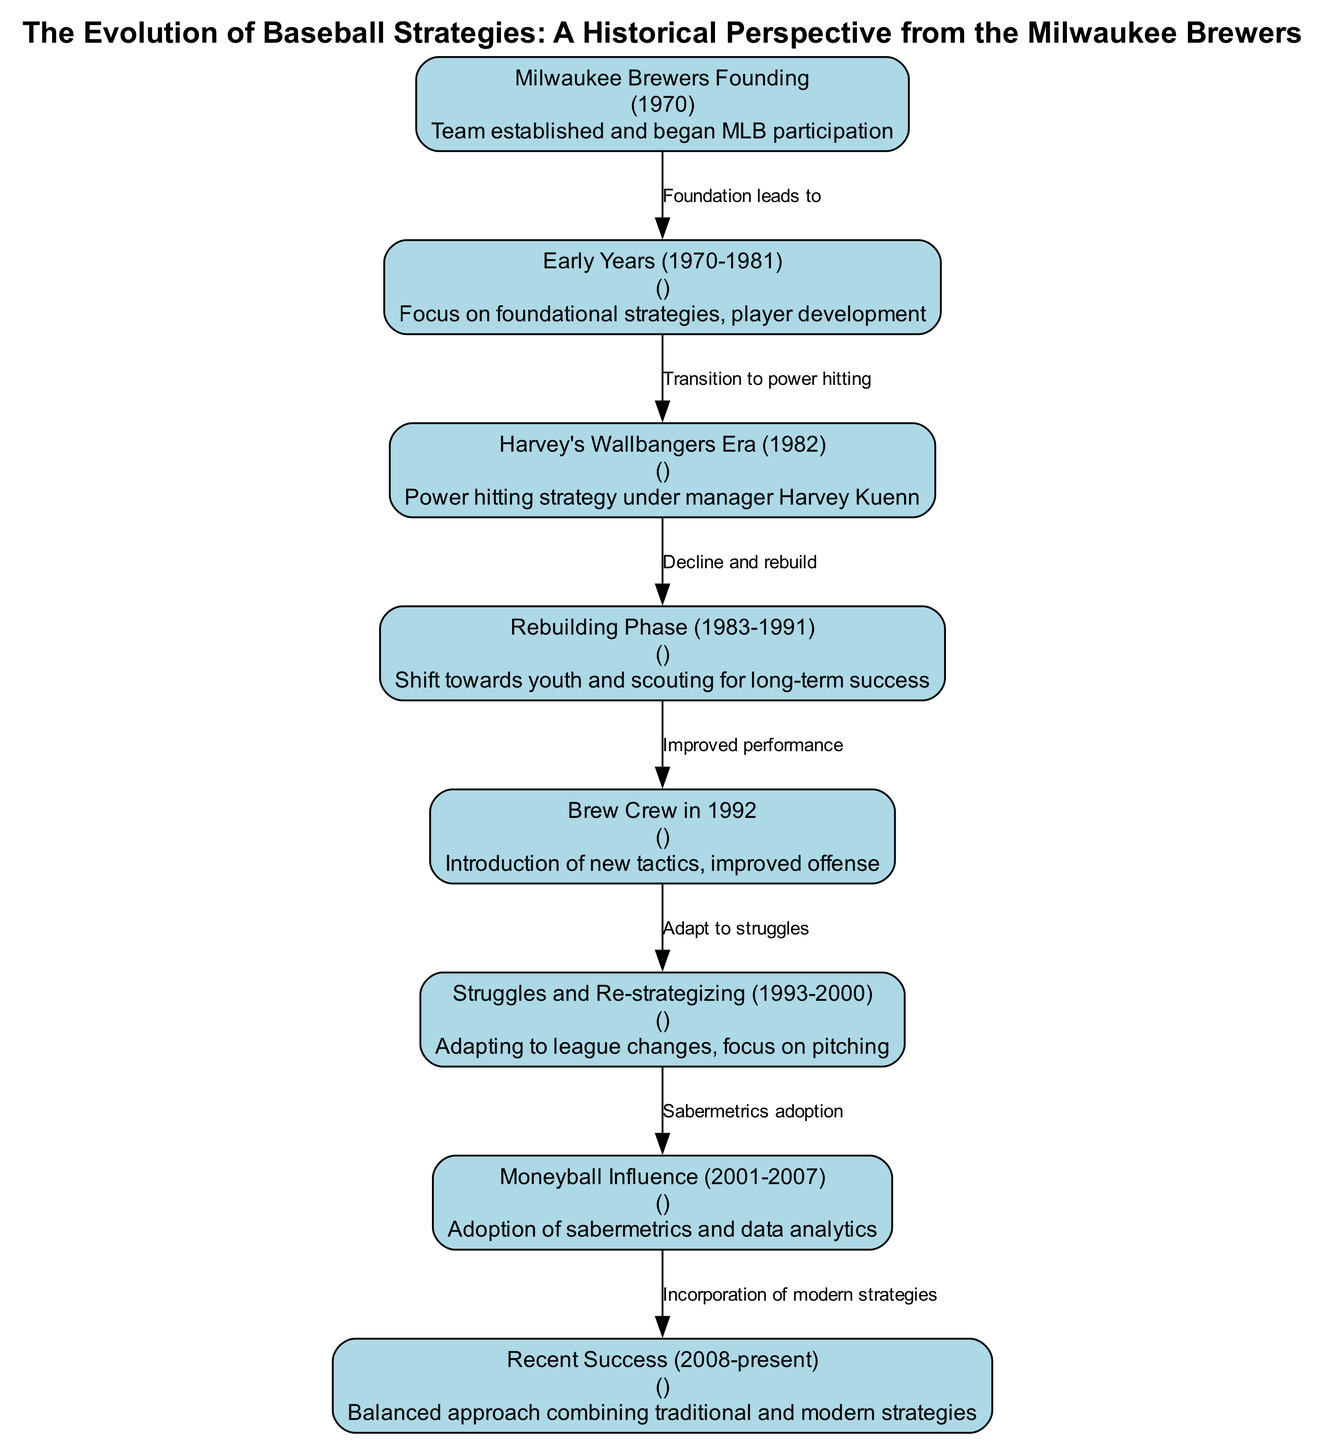What year was the Milwaukee Brewers founded? The diagram indicates that the Milwaukee Brewers were founded in 1970, as shown in the "Milwaukee Brewers Founding" node.
Answer: 1970 What transition did the Brewers make after the Early Years? The edge connecting "Early Years (1970-1981)" and "Harvey's Wallbangers Era (1982)" indicates a transition to a power hitting strategy.
Answer: Power hitting How many major phases or strategies are outlined in the diagram? By counting the nodes represented in the diagram, we find there are eight nodes that correspond to different phases or strategies in the evolution of the Milwaukee Brewers.
Answer: 8 What did the Brewers focus on during the Rebuilding Phase? The description of the "Rebuilding Phase (1983-1991)" node states that the focus was on youth and scouting for long-term success, which is the key theme of that phase.
Answer: Youth and scouting What strategy did the Brewers adopt from 2001 to 2007? The "Moneyball Influence (2001-2007)" node indicates that during this period, the Brewers adopted sabermetrics and data analytics as a key strategy.
Answer: Sabermetrics and data analytics What does the transition from the Struggles and Re-strategizing phase to the Moneyball Influence indicate? The edge shows that the transition from "Struggles and Re-strategizing (1993-2000)" to "Moneyball Influence (2001-2007)" indicates an adaptation and incorporation of analytics into their strategy. This reflects an evolution in how the team approached player performance metrics.
Answer: Adaptation to analytics How did recent success (2008-present) combine different strategies? The "Recent Success (2008-present)" node mentions a balanced approach that combines traditional and modern strategies, suggesting that the Brewers integrated both old and new methodologies in their tactics.
Answer: Balanced approach combining old and new What key concept is illustrated by the edges connecting each phase? The edges represent the relationships and transitions between different baseball strategies over time, illustrating the evolution and progression that the Milwaukee Brewers experienced through their history.
Answer: Evolution of strategies 